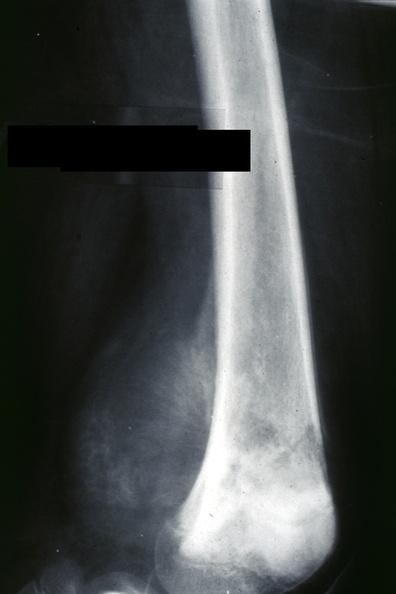what does this image show?
Answer the question using a single word or phrase. X-ray distal femur lateral view lytic and blastic lesion 